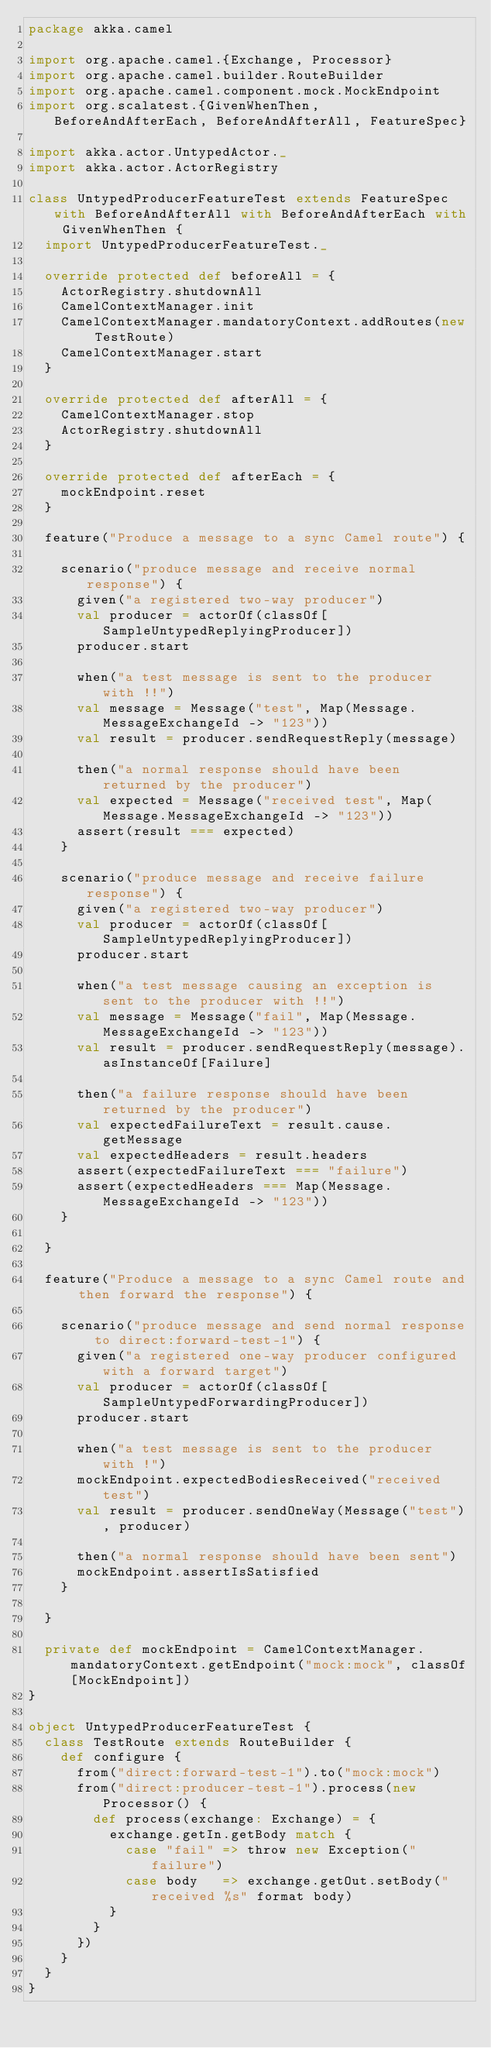Convert code to text. <code><loc_0><loc_0><loc_500><loc_500><_Scala_>package akka.camel

import org.apache.camel.{Exchange, Processor}
import org.apache.camel.builder.RouteBuilder
import org.apache.camel.component.mock.MockEndpoint
import org.scalatest.{GivenWhenThen, BeforeAndAfterEach, BeforeAndAfterAll, FeatureSpec}

import akka.actor.UntypedActor._
import akka.actor.ActorRegistry

class UntypedProducerFeatureTest extends FeatureSpec with BeforeAndAfterAll with BeforeAndAfterEach with GivenWhenThen {
  import UntypedProducerFeatureTest._

  override protected def beforeAll = {
    ActorRegistry.shutdownAll
    CamelContextManager.init
    CamelContextManager.mandatoryContext.addRoutes(new TestRoute)
    CamelContextManager.start
  }

  override protected def afterAll = {
    CamelContextManager.stop
    ActorRegistry.shutdownAll
  }

  override protected def afterEach = {
    mockEndpoint.reset
  }

  feature("Produce a message to a sync Camel route") {

    scenario("produce message and receive normal response") {
      given("a registered two-way producer")
      val producer = actorOf(classOf[SampleUntypedReplyingProducer])
      producer.start

      when("a test message is sent to the producer with !!")
      val message = Message("test", Map(Message.MessageExchangeId -> "123"))
      val result = producer.sendRequestReply(message)

      then("a normal response should have been returned by the producer")
      val expected = Message("received test", Map(Message.MessageExchangeId -> "123"))
      assert(result === expected)
    }

    scenario("produce message and receive failure response") {
      given("a registered two-way producer")
      val producer = actorOf(classOf[SampleUntypedReplyingProducer])
      producer.start

      when("a test message causing an exception is sent to the producer with !!")
      val message = Message("fail", Map(Message.MessageExchangeId -> "123"))
      val result = producer.sendRequestReply(message).asInstanceOf[Failure]

      then("a failure response should have been returned by the producer")
      val expectedFailureText = result.cause.getMessage
      val expectedHeaders = result.headers
      assert(expectedFailureText === "failure")
      assert(expectedHeaders === Map(Message.MessageExchangeId -> "123"))
    }

  }

  feature("Produce a message to a sync Camel route and then forward the response") {

    scenario("produce message and send normal response to direct:forward-test-1") {
      given("a registered one-way producer configured with a forward target")
      val producer = actorOf(classOf[SampleUntypedForwardingProducer])
      producer.start

      when("a test message is sent to the producer with !")
      mockEndpoint.expectedBodiesReceived("received test")
      val result = producer.sendOneWay(Message("test"), producer)

      then("a normal response should have been sent")
      mockEndpoint.assertIsSatisfied
    }

  }

  private def mockEndpoint = CamelContextManager.mandatoryContext.getEndpoint("mock:mock", classOf[MockEndpoint])
}

object UntypedProducerFeatureTest {
  class TestRoute extends RouteBuilder {
    def configure {
      from("direct:forward-test-1").to("mock:mock")
      from("direct:producer-test-1").process(new Processor() {
        def process(exchange: Exchange) = {
          exchange.getIn.getBody match {
            case "fail" => throw new Exception("failure")
            case body   => exchange.getOut.setBody("received %s" format body)
          }
        }
      })
    }
  }
}
</code> 